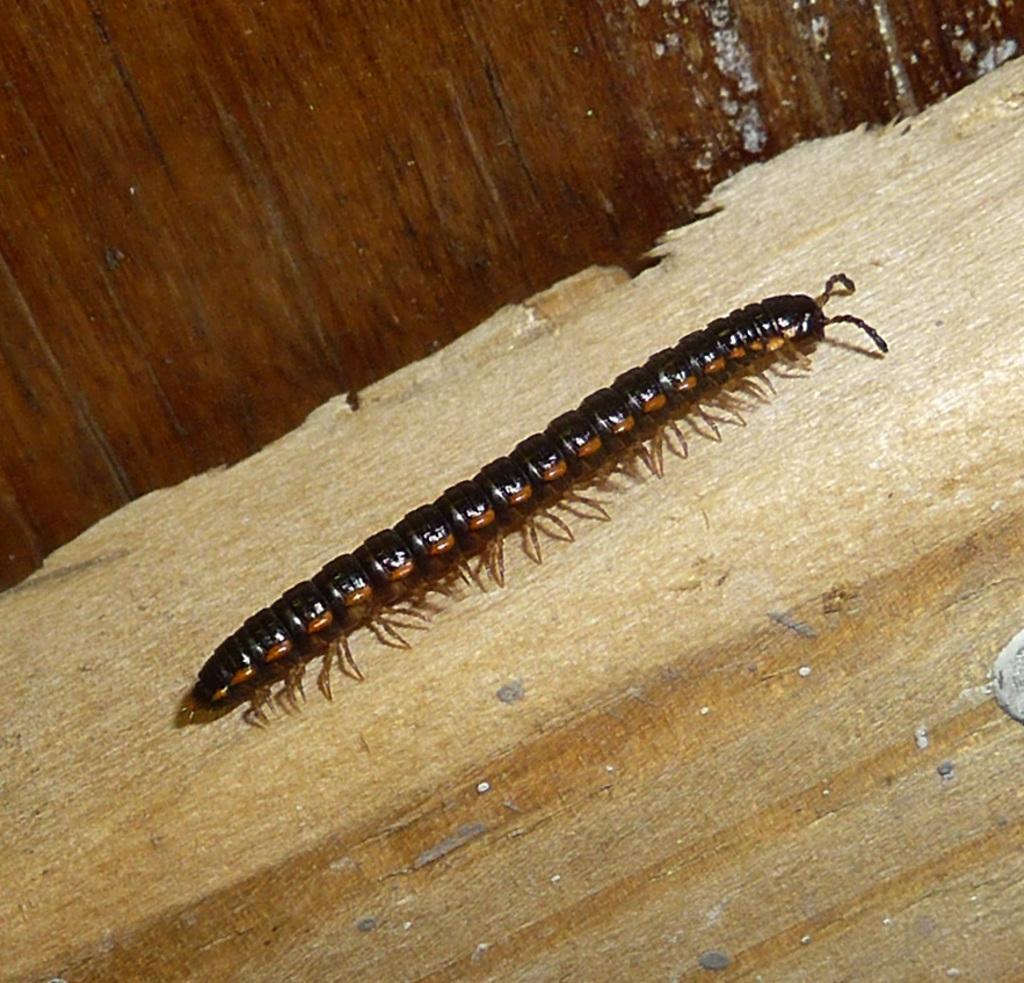In one or two sentences, can you explain what this image depicts? In the center of the image there is a wood. On the wood,we can see one insect,which is in black color. In the background there is a wooden wall. 